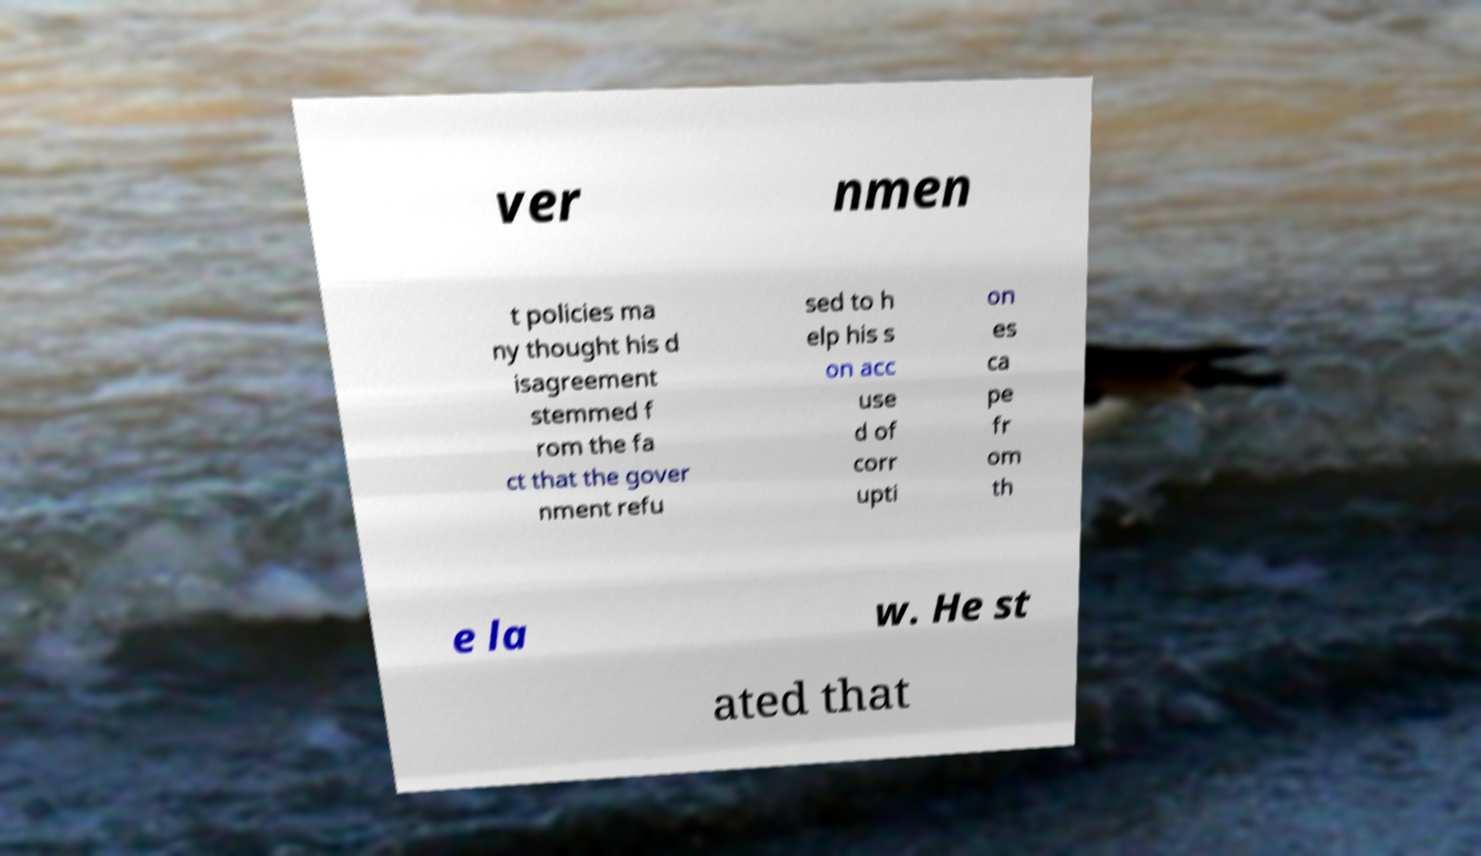For documentation purposes, I need the text within this image transcribed. Could you provide that? ver nmen t policies ma ny thought his d isagreement stemmed f rom the fa ct that the gover nment refu sed to h elp his s on acc use d of corr upti on es ca pe fr om th e la w. He st ated that 